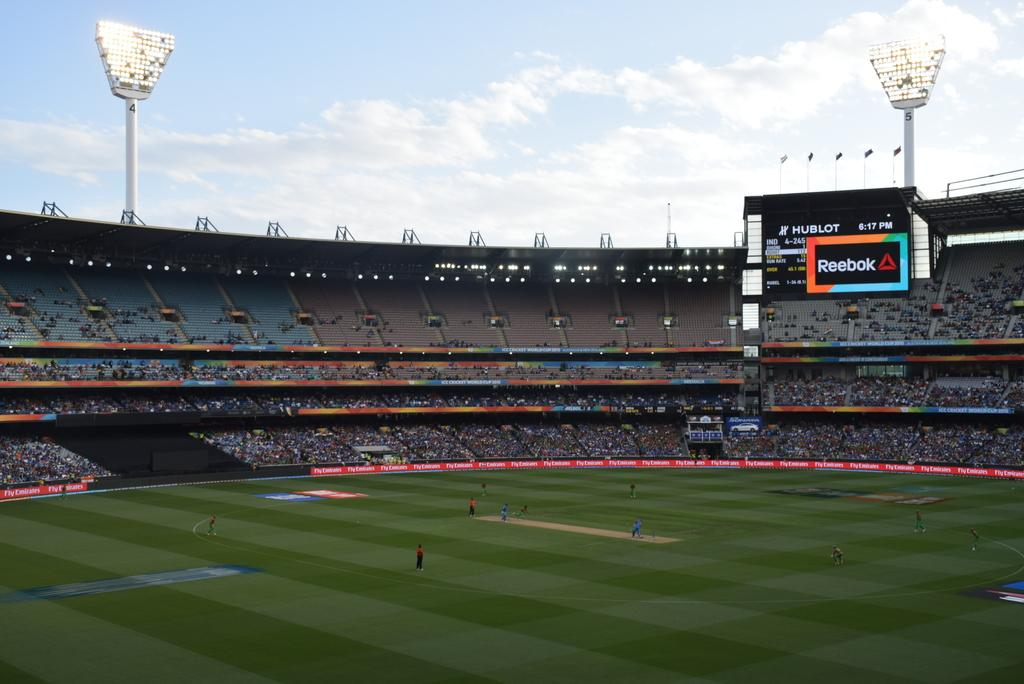Provide a one-sentence caption for the provided image. A baseball game is underway in the Reebok stadium. 